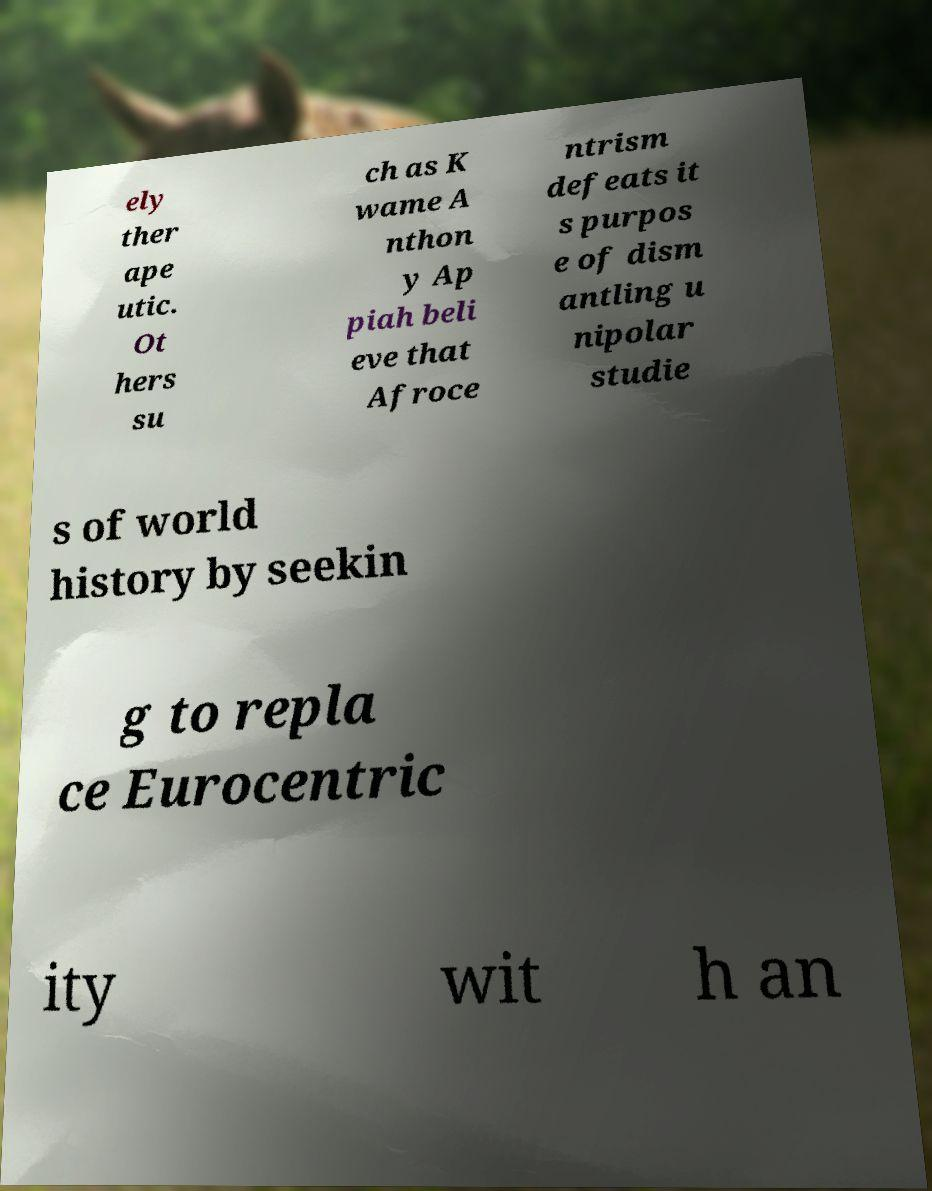There's text embedded in this image that I need extracted. Can you transcribe it verbatim? ely ther ape utic. Ot hers su ch as K wame A nthon y Ap piah beli eve that Afroce ntrism defeats it s purpos e of dism antling u nipolar studie s of world history by seekin g to repla ce Eurocentric ity wit h an 